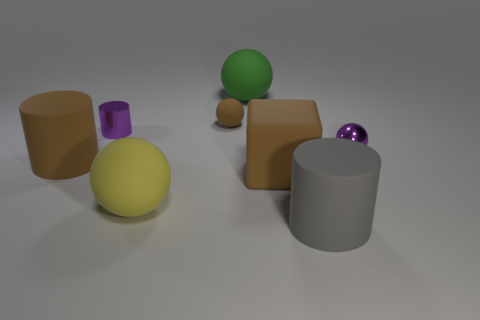What number of large gray cylinders have the same material as the big brown cylinder?
Offer a very short reply. 1. What size is the purple thing left of the gray rubber object?
Provide a succinct answer. Small. What shape is the purple shiny object behind the purple object on the right side of the gray object?
Your response must be concise. Cylinder. How many green objects are to the left of the large rubber ball in front of the purple metallic thing that is on the right side of the green rubber object?
Give a very brief answer. 0. Are there fewer cylinders behind the cube than big yellow balls?
Give a very brief answer. No. Is there any other thing that has the same shape as the yellow matte thing?
Make the answer very short. Yes. What shape is the tiny object that is to the left of the brown rubber sphere?
Provide a short and direct response. Cylinder. There is a purple object on the left side of the gray cylinder that is in front of the brown rubber object that is right of the big green object; what is its shape?
Offer a very short reply. Cylinder. What number of things are either big gray balls or purple things?
Provide a succinct answer. 2. There is a tiny purple object that is behind the purple shiny ball; does it have the same shape as the purple metallic object on the right side of the big gray cylinder?
Provide a short and direct response. No. 